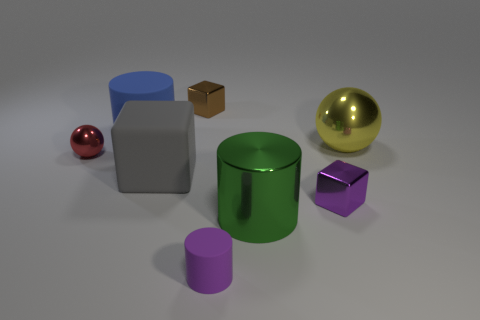There is a tiny purple object that is on the right side of the green metallic cylinder; is it the same shape as the metallic object behind the big blue thing?
Keep it short and to the point. Yes. Are there more big cylinders behind the large yellow object than tiny red matte blocks?
Give a very brief answer. Yes. What number of objects are either large yellow things or blue rubber cylinders?
Give a very brief answer. 2. What color is the big rubber block?
Make the answer very short. Gray. How many other objects are the same color as the large metal cylinder?
Offer a very short reply. 0. Are there any shiny balls to the right of the big yellow metal ball?
Offer a very short reply. No. There is a small cube that is right of the purple thing on the left side of the metal cylinder on the right side of the tiny purple cylinder; what color is it?
Your answer should be compact. Purple. What number of tiny objects are in front of the green metallic thing and behind the big shiny sphere?
Make the answer very short. 0. How many cubes are either large gray matte things or blue objects?
Provide a succinct answer. 1. Are there any big gray spheres?
Make the answer very short. No. 